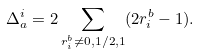Convert formula to latex. <formula><loc_0><loc_0><loc_500><loc_500>\Delta _ { a } ^ { i } = 2 \sum _ { r ^ { b } _ { i } \neq 0 , 1 / 2 , 1 } ( 2 r ^ { b } _ { i } - 1 ) .</formula> 